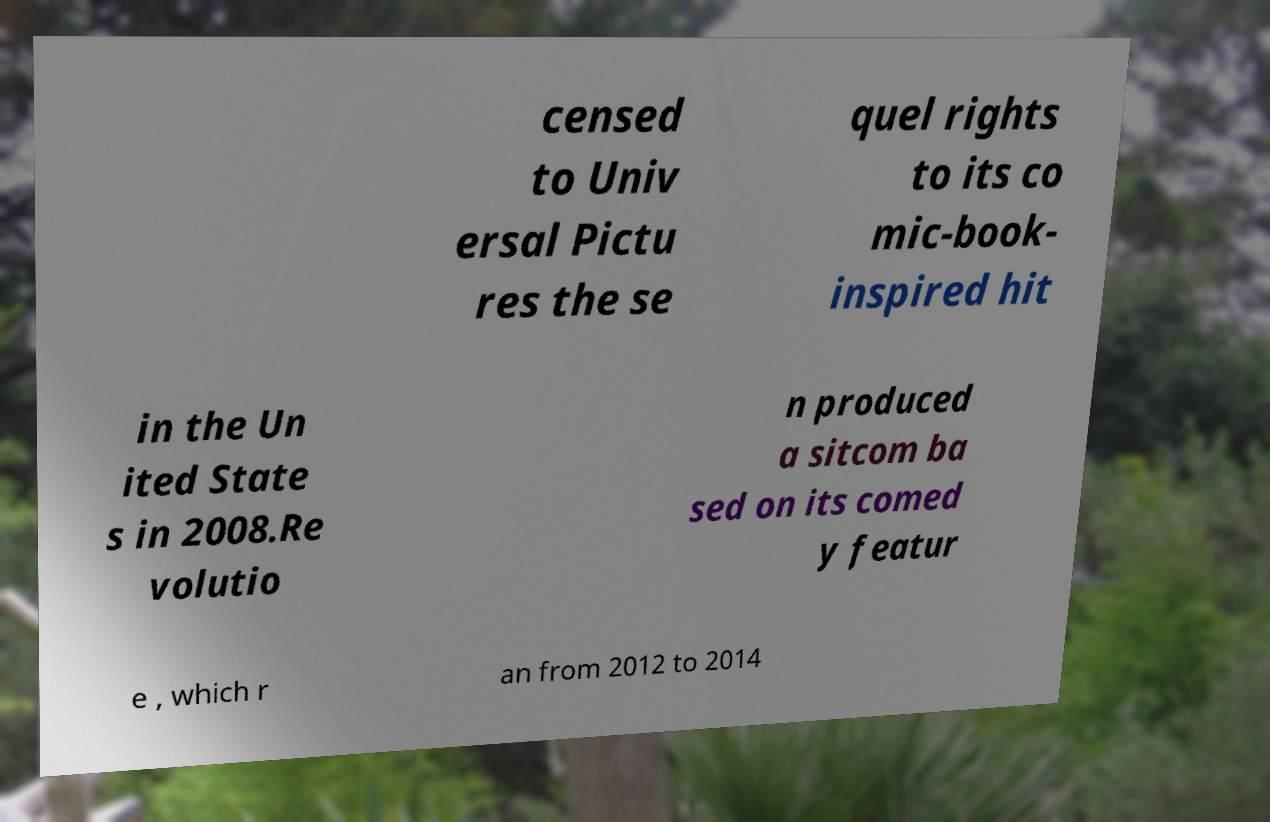Could you assist in decoding the text presented in this image and type it out clearly? censed to Univ ersal Pictu res the se quel rights to its co mic-book- inspired hit in the Un ited State s in 2008.Re volutio n produced a sitcom ba sed on its comed y featur e , which r an from 2012 to 2014 